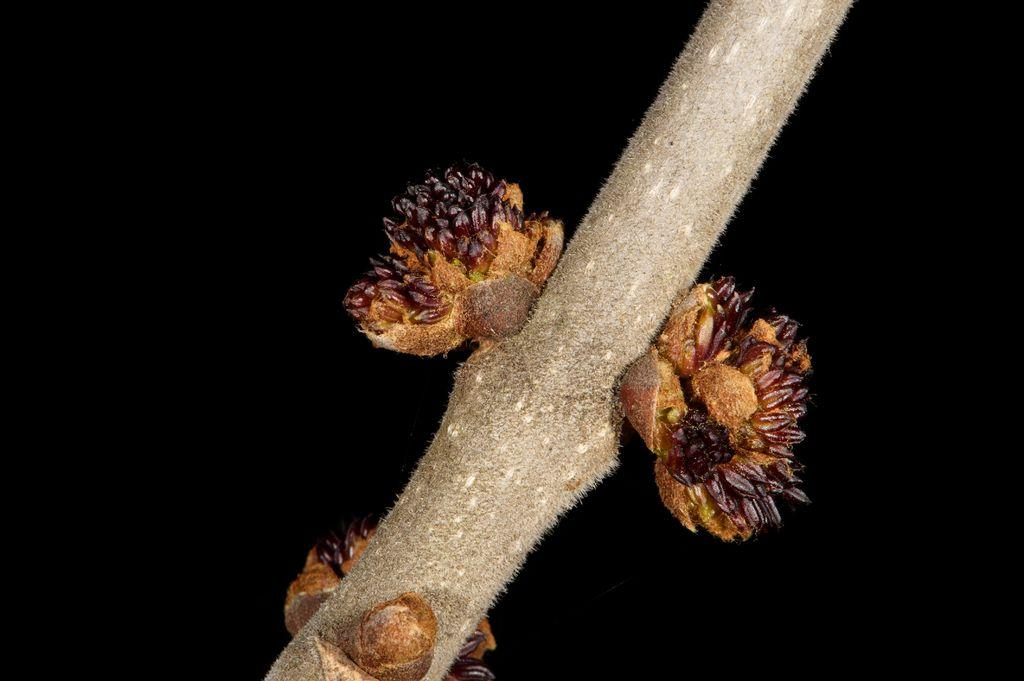What is the main subject of the image? The main subject of the image is a stem with stony corals. What can be seen in the background of the image? The background of the image is dark. How many people are in the crowd in the image? There is no crowd present in the image; it features a stem with stony corals. What type of nose can be seen on the line in the image? There is no line or nose present in the image. 